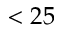Convert formula to latex. <formula><loc_0><loc_0><loc_500><loc_500>< 2 5</formula> 